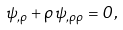<formula> <loc_0><loc_0><loc_500><loc_500>\psi _ { , \rho } + \rho \, \psi _ { , \rho \rho } = 0 ,</formula> 